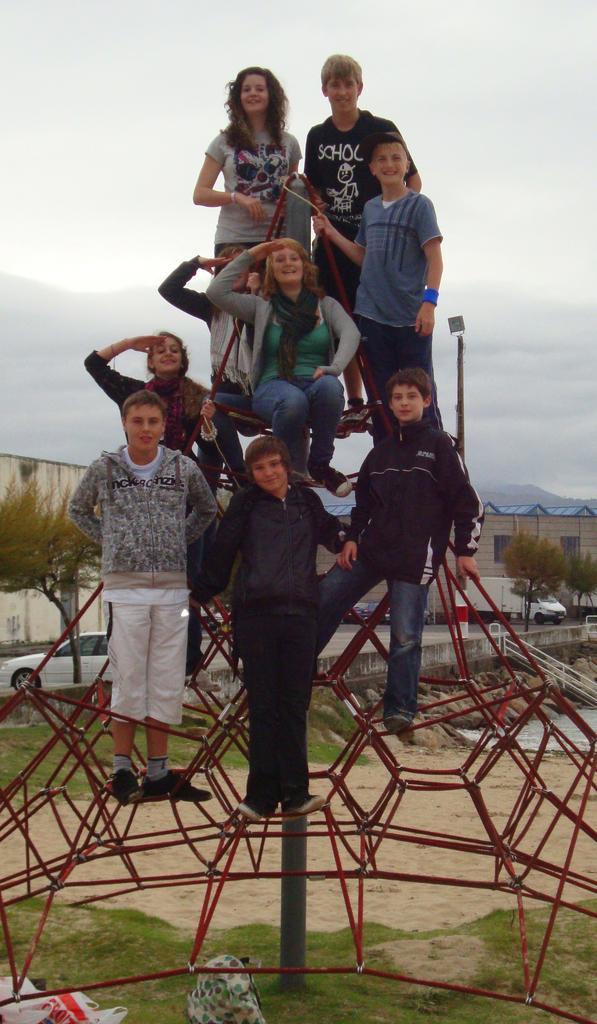Describe this image in one or two sentences. In this image, we can see a group of people are on the rods. Few are watching and smiling. At the bottom, we can see grass, few objects. Here there is a pole. Background we can see trees, vehicles, houses, stones, poles and sky. 